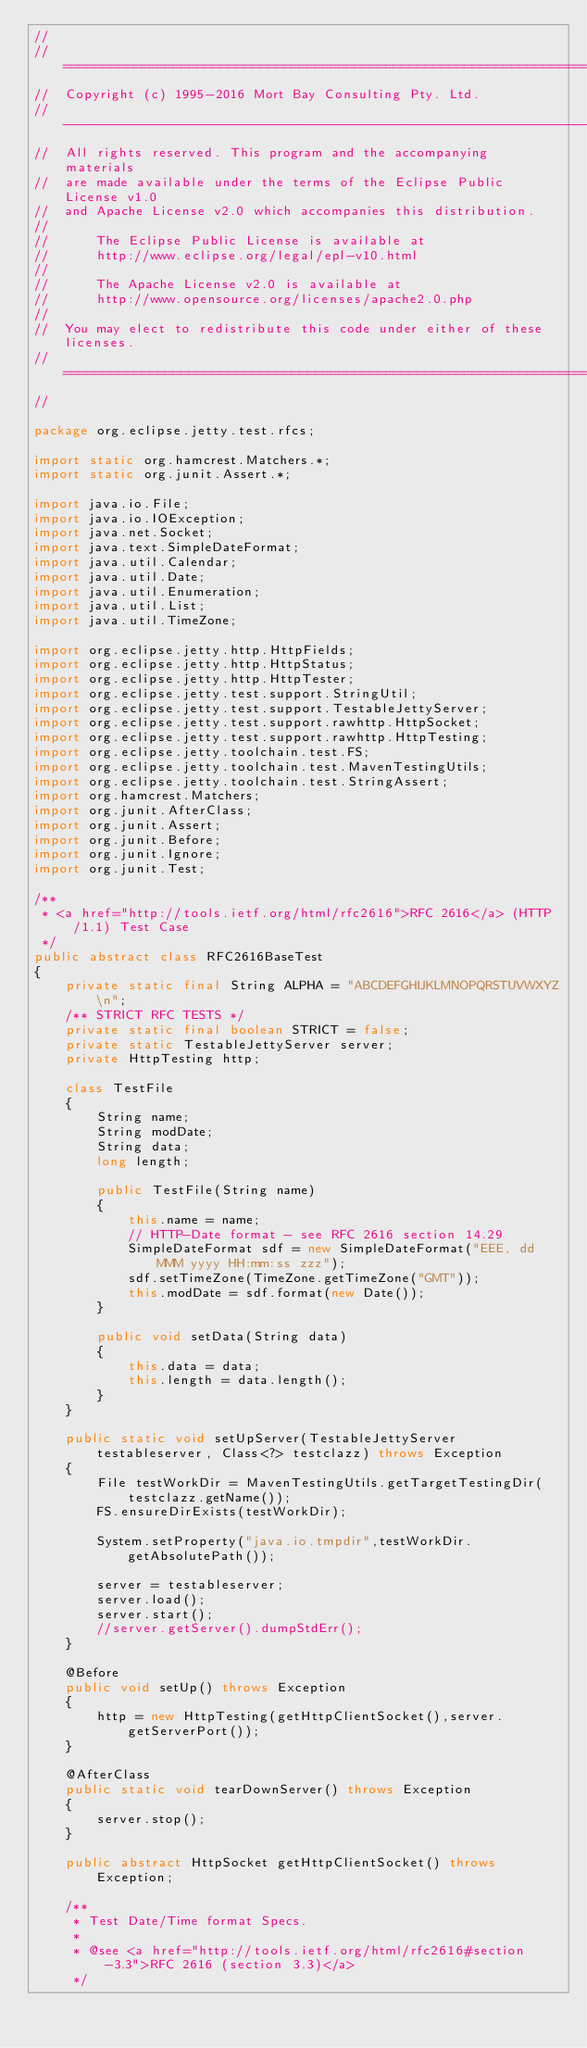Convert code to text. <code><loc_0><loc_0><loc_500><loc_500><_Java_>//
//  ========================================================================
//  Copyright (c) 1995-2016 Mort Bay Consulting Pty. Ltd.
//  ------------------------------------------------------------------------
//  All rights reserved. This program and the accompanying materials
//  are made available under the terms of the Eclipse Public License v1.0
//  and Apache License v2.0 which accompanies this distribution.
//
//      The Eclipse Public License is available at
//      http://www.eclipse.org/legal/epl-v10.html
//
//      The Apache License v2.0 is available at
//      http://www.opensource.org/licenses/apache2.0.php
//
//  You may elect to redistribute this code under either of these licenses.
//  ========================================================================
//

package org.eclipse.jetty.test.rfcs;

import static org.hamcrest.Matchers.*;
import static org.junit.Assert.*;

import java.io.File;
import java.io.IOException;
import java.net.Socket;
import java.text.SimpleDateFormat;
import java.util.Calendar;
import java.util.Date;
import java.util.Enumeration;
import java.util.List;
import java.util.TimeZone;

import org.eclipse.jetty.http.HttpFields;
import org.eclipse.jetty.http.HttpStatus;
import org.eclipse.jetty.http.HttpTester;
import org.eclipse.jetty.test.support.StringUtil;
import org.eclipse.jetty.test.support.TestableJettyServer;
import org.eclipse.jetty.test.support.rawhttp.HttpSocket;
import org.eclipse.jetty.test.support.rawhttp.HttpTesting;
import org.eclipse.jetty.toolchain.test.FS;
import org.eclipse.jetty.toolchain.test.MavenTestingUtils;
import org.eclipse.jetty.toolchain.test.StringAssert;
import org.hamcrest.Matchers;
import org.junit.AfterClass;
import org.junit.Assert;
import org.junit.Before;
import org.junit.Ignore;
import org.junit.Test;

/**
 * <a href="http://tools.ietf.org/html/rfc2616">RFC 2616</a> (HTTP/1.1) Test Case
 */
public abstract class RFC2616BaseTest
{
    private static final String ALPHA = "ABCDEFGHIJKLMNOPQRSTUVWXYZ\n";
    /** STRICT RFC TESTS */
    private static final boolean STRICT = false;
    private static TestableJettyServer server;
    private HttpTesting http;

    class TestFile
    {
        String name;
        String modDate;
        String data;
        long length;

        public TestFile(String name)
        {
            this.name = name;
            // HTTP-Date format - see RFC 2616 section 14.29
            SimpleDateFormat sdf = new SimpleDateFormat("EEE, dd MMM yyyy HH:mm:ss zzz");
            sdf.setTimeZone(TimeZone.getTimeZone("GMT"));
            this.modDate = sdf.format(new Date());
        }

        public void setData(String data)
        {
            this.data = data;
            this.length = data.length();
        }
    }

    public static void setUpServer(TestableJettyServer testableserver, Class<?> testclazz) throws Exception
    {
        File testWorkDir = MavenTestingUtils.getTargetTestingDir(testclazz.getName());
        FS.ensureDirExists(testWorkDir);

        System.setProperty("java.io.tmpdir",testWorkDir.getAbsolutePath());

        server = testableserver;
        server.load();
        server.start();
        //server.getServer().dumpStdErr();
    }
    
    @Before
    public void setUp() throws Exception
    {
        http = new HttpTesting(getHttpClientSocket(),server.getServerPort());
    }

    @AfterClass
    public static void tearDownServer() throws Exception
    {
        server.stop();
    }

    public abstract HttpSocket getHttpClientSocket() throws Exception;

    /**
     * Test Date/Time format Specs.
     * 
     * @see <a href="http://tools.ietf.org/html/rfc2616#section-3.3">RFC 2616 (section 3.3)</a>
     */</code> 